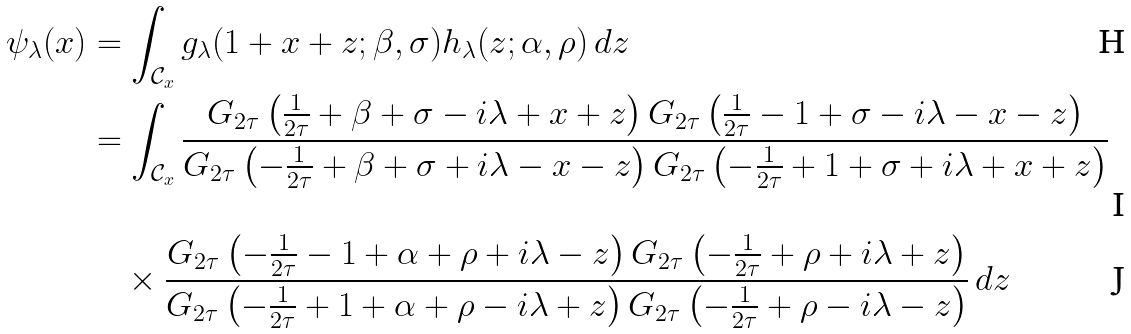Convert formula to latex. <formula><loc_0><loc_0><loc_500><loc_500>\psi _ { \lambda } ( x ) & = \int _ { \mathcal { C } _ { x } } g _ { \lambda } ( 1 + x + z ; \beta , \sigma ) h _ { \lambda } ( z ; \alpha , \rho ) \, d z \\ & = \int _ { \mathcal { C } _ { x } } \frac { G _ { 2 \tau } \left ( \frac { 1 } { 2 \tau } + \beta + \sigma - i \lambda + x + z \right ) G _ { 2 \tau } \left ( \frac { 1 } { 2 \tau } - 1 + \sigma - i \lambda - x - z \right ) } { G _ { 2 \tau } \left ( - \frac { 1 } { 2 \tau } + \beta + \sigma + i \lambda - x - z \right ) G _ { 2 \tau } \left ( - \frac { 1 } { 2 \tau } + 1 + \sigma + i \lambda + x + z \right ) } \\ & \quad \times \frac { G _ { 2 \tau } \left ( - \frac { 1 } { 2 \tau } - 1 + \alpha + \rho + i \lambda - z \right ) G _ { 2 \tau } \left ( - \frac { 1 } { 2 \tau } + \rho + i \lambda + z \right ) } { G _ { 2 \tau } \left ( - \frac { 1 } { 2 \tau } + 1 + \alpha + \rho - i \lambda + z \right ) G _ { 2 \tau } \left ( - \frac { 1 } { 2 \tau } + \rho - i \lambda - z \right ) } \, d z</formula> 